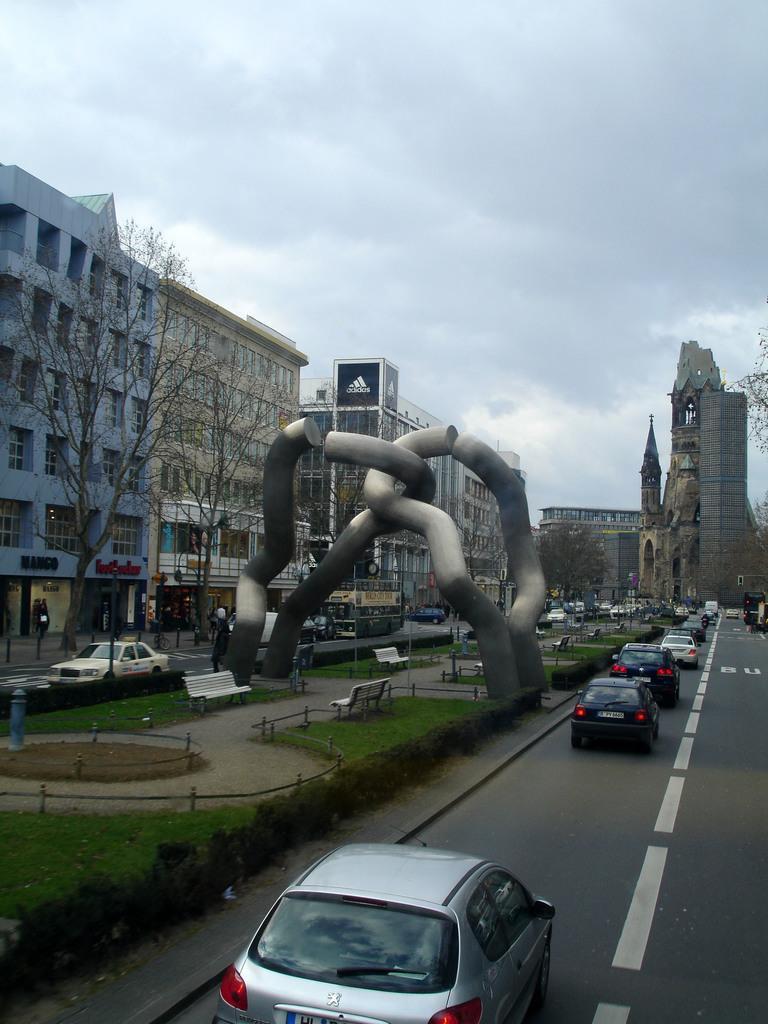Describe this image in one or two sentences. In the picture we can see a road with some vehicles on it and besides it we can see a grass surface with railing and some chain joint sculpture and besides we can see another road and on it we can see a car and in the background we can see some trees and buildings and behind it we can see sky and clouds. 